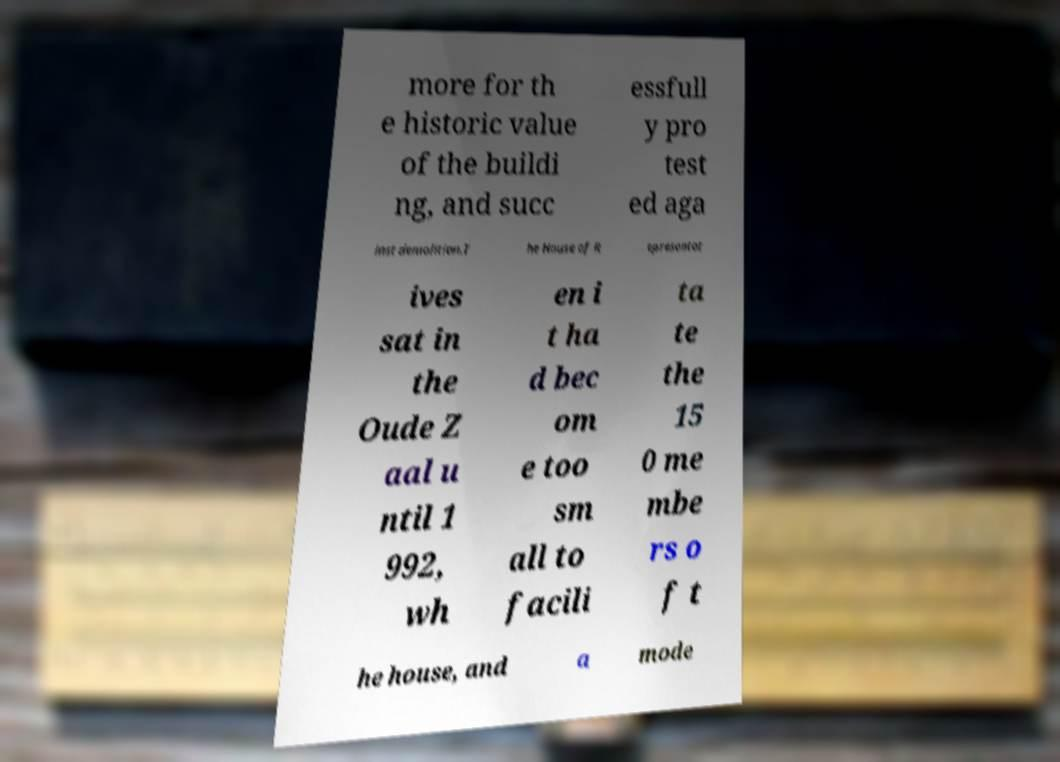Could you extract and type out the text from this image? more for th e historic value of the buildi ng, and succ essfull y pro test ed aga inst demolition.T he House of R epresentat ives sat in the Oude Z aal u ntil 1 992, wh en i t ha d bec om e too sm all to facili ta te the 15 0 me mbe rs o f t he house, and a mode 